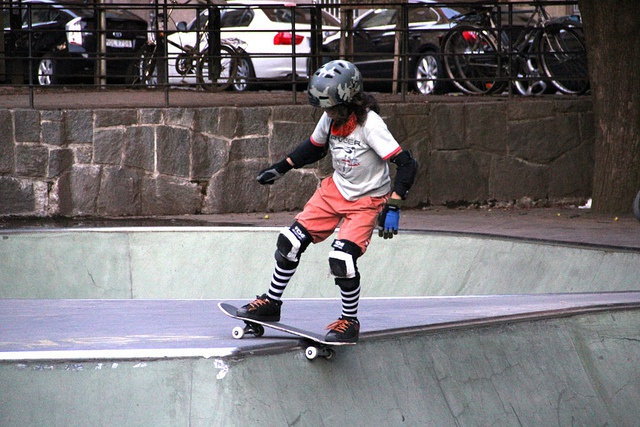Describe the objects in this image and their specific colors. I can see people in black, white, darkgray, and gray tones, car in black, white, gray, and darkgray tones, car in black, gray, white, and darkgray tones, bicycle in black, gray, and darkgray tones, and car in black, gray, and white tones in this image. 